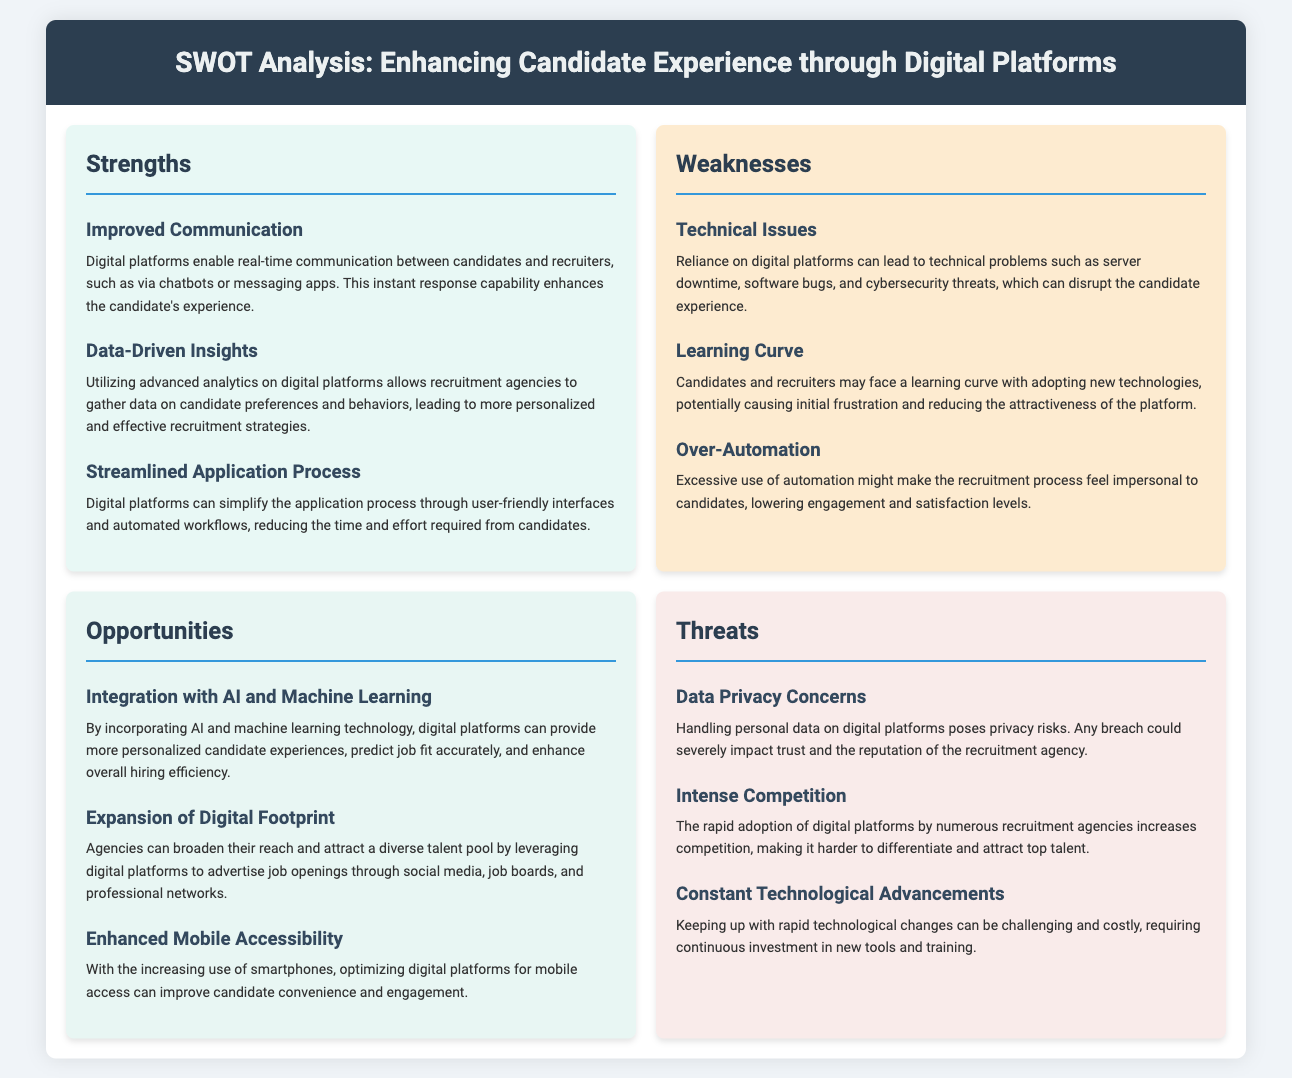What is a strength that enhances candidate experience? One of the strengths listed is "Improved Communication," which refers to the capability for real-time communication.
Answer: Improved Communication What is a weakness related to digital platforms? A mentioned weakness is "Technical Issues," indicating reliance on technology can lead to disruptions.
Answer: Technical Issues What opportunity involves new technology? The opportunity that involves new technology is "Integration with AI and Machine Learning," which can personalize experiences.
Answer: Integration with AI and Machine Learning How many strengths are identified in the analysis? There are three strengths listed under the Strengths section.
Answer: 3 What is a threat associated with personal data? The threat related to personal data is "Data Privacy Concerns," which highlights risks of handling personal data.
Answer: Data Privacy Concerns What is a potential opportunity for recruitment agencies? One opportunity includes "Expansion of Digital Footprint," allowing agencies to reach a diverse talent pool.
Answer: Expansion of Digital Footprint Which section discusses the risk of losing trust? The section discussing the risk of losing trust is "Threats," specifically under "Data Privacy Concerns."
Answer: Threats What is a potential negative effect of over-automation? Over-automation might lower engagement and satisfaction levels for candidates.
Answer: Lower engagement and satisfaction levels What aspect of mobile devices is mentioned as an opportunity? "Enhanced Mobile Accessibility" is noted as an opportunity for improving candidate engagement.
Answer: Enhanced Mobile Accessibility 